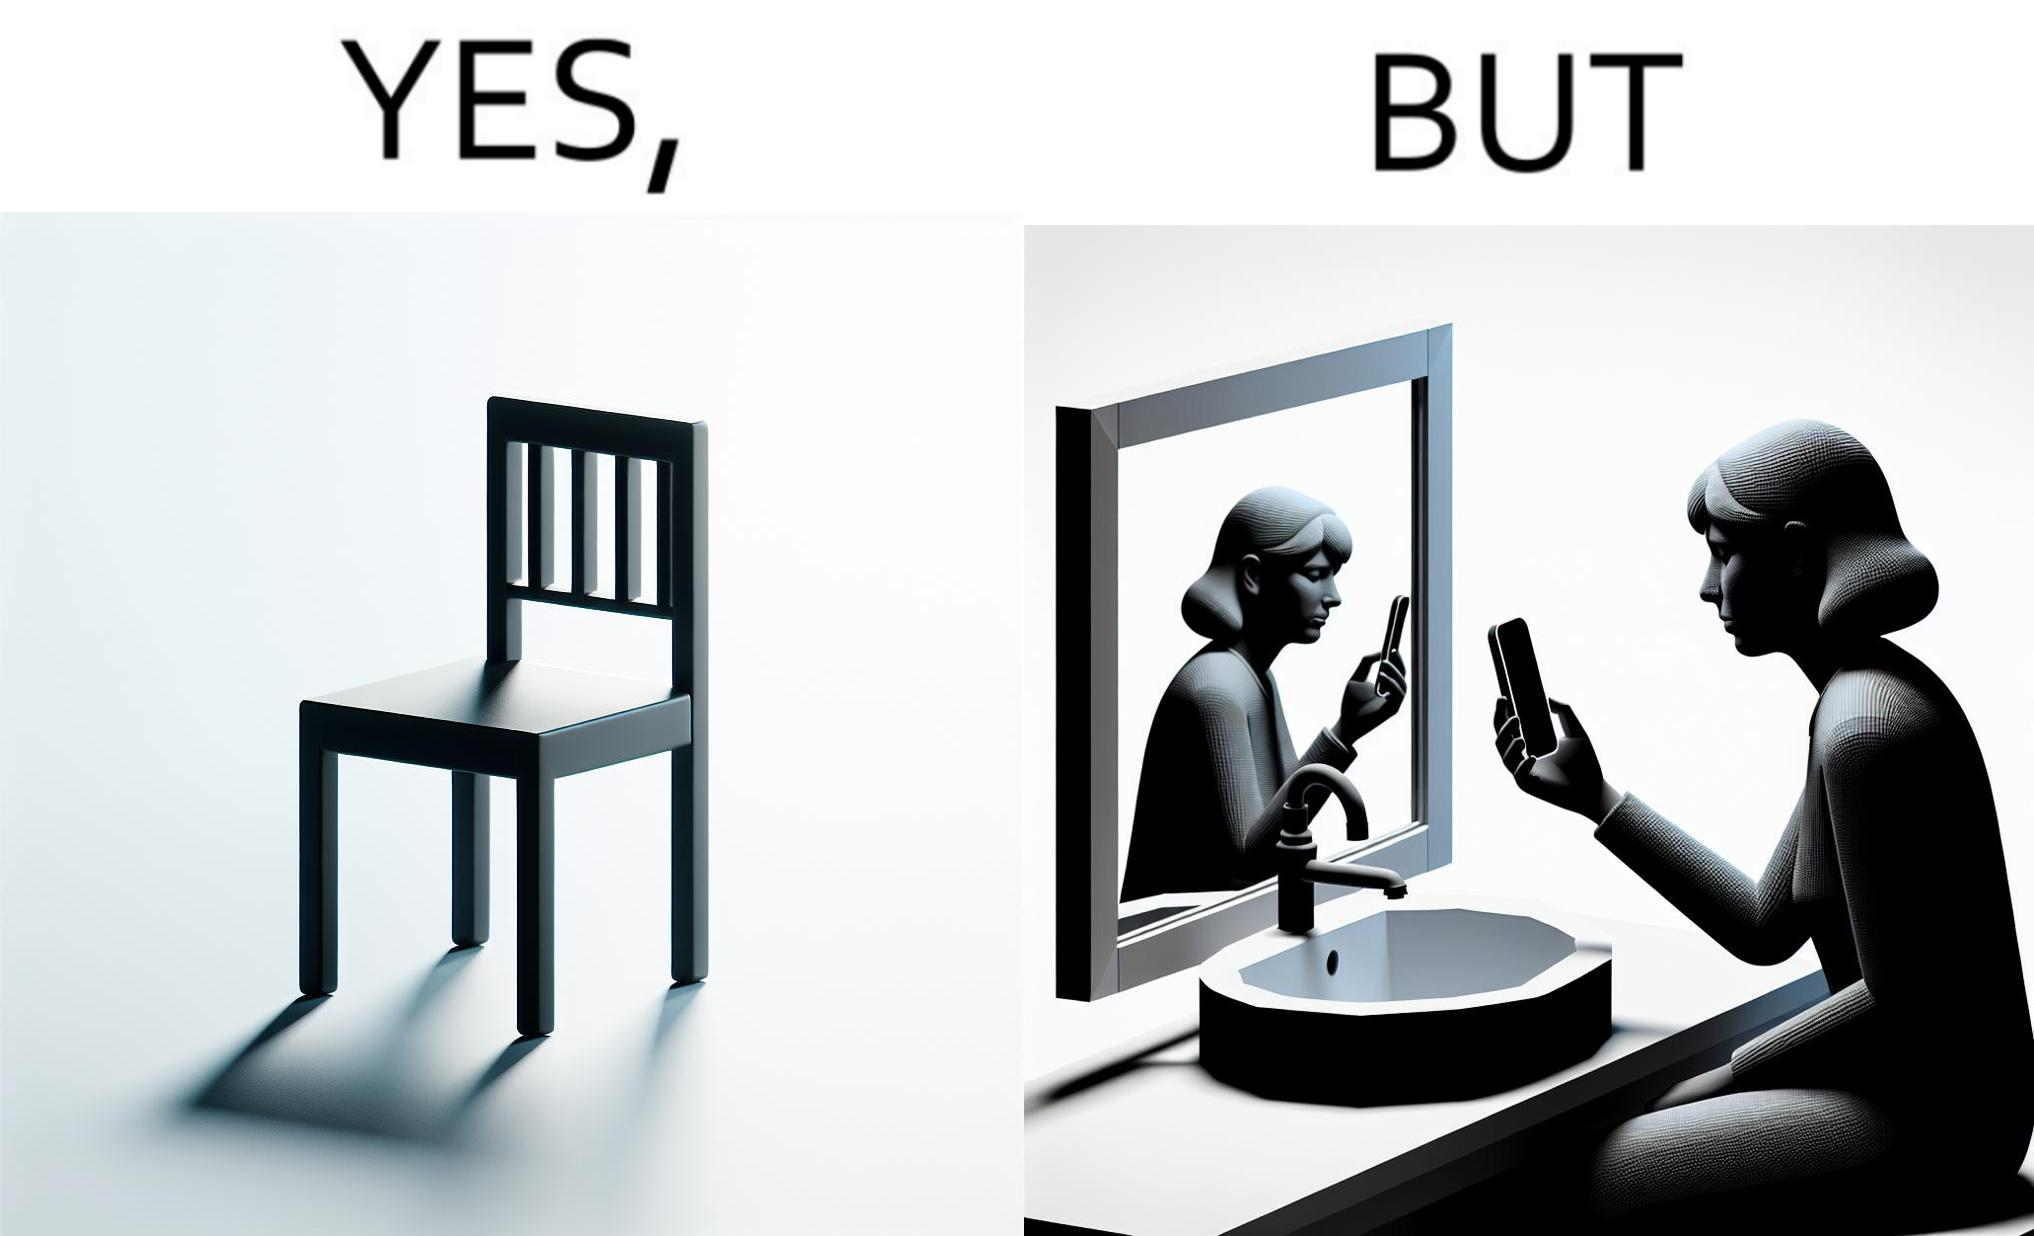What is shown in the left half versus the right half of this image? In the left part of the image: a chair. In the right part of the image: a woman sitting by the sink taking a selfie using a mirror. 